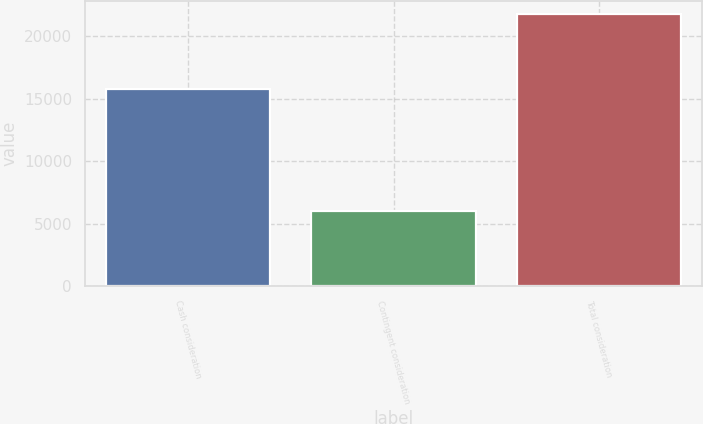Convert chart. <chart><loc_0><loc_0><loc_500><loc_500><bar_chart><fcel>Cash consideration<fcel>Contingent consideration<fcel>Total consideration<nl><fcel>15750<fcel>6000<fcel>21750<nl></chart> 